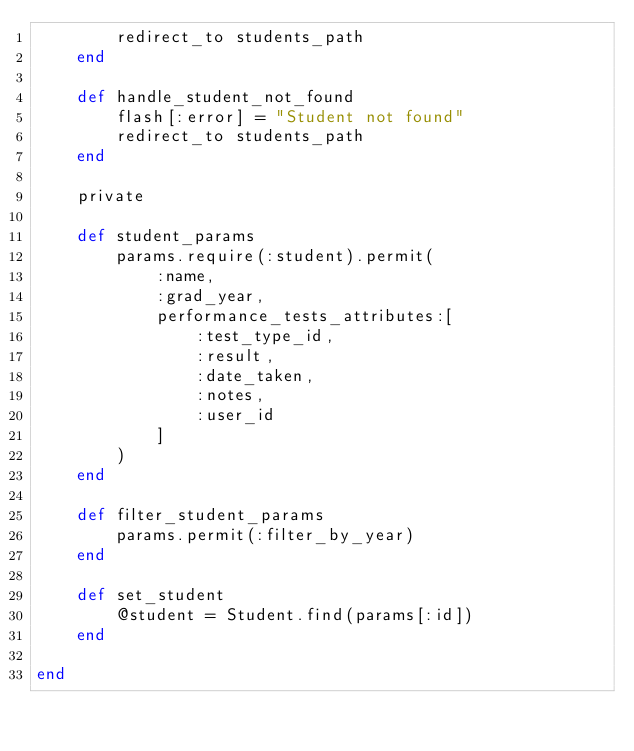<code> <loc_0><loc_0><loc_500><loc_500><_Ruby_>        redirect_to students_path
    end

    def handle_student_not_found
        flash[:error] = "Student not found"
        redirect_to students_path
    end

    private

    def student_params
        params.require(:student).permit(
            :name, 
            :grad_year, 
            performance_tests_attributes:[
                :test_type_id,
                :result,
                :date_taken,
                :notes,
                :user_id
            ]
        )
    end 

    def filter_student_params
        params.permit(:filter_by_year)
    end 

    def set_student
        @student = Student.find(params[:id])
    end

end
</code> 